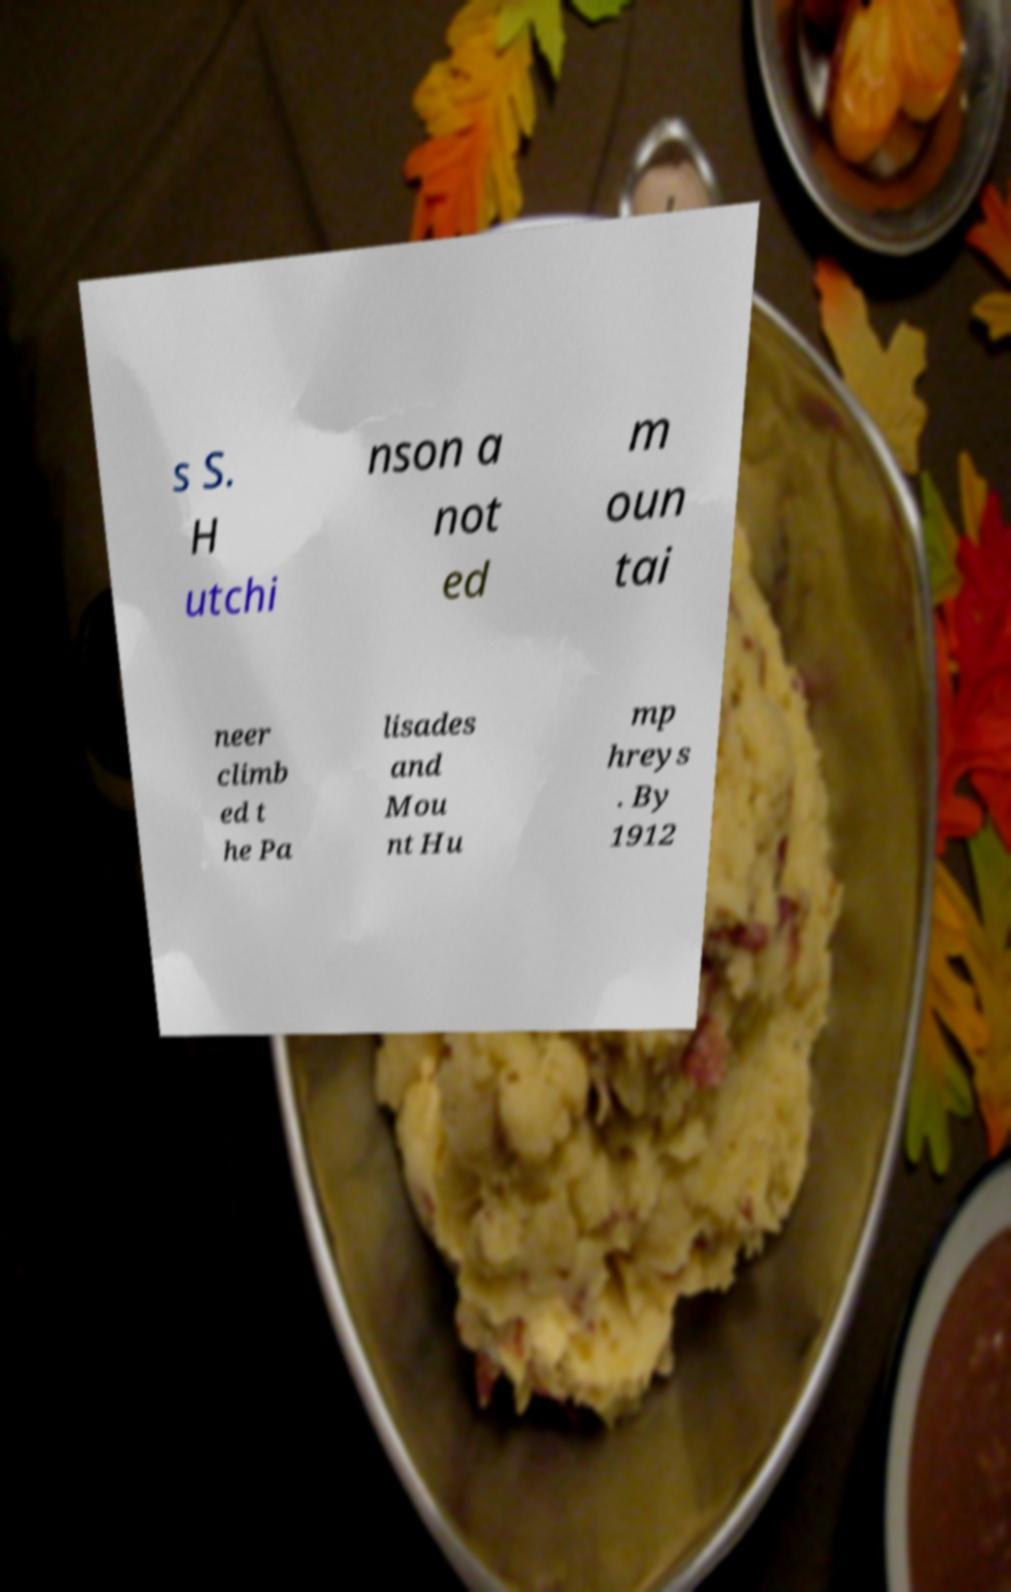Please identify and transcribe the text found in this image. s S. H utchi nson a not ed m oun tai neer climb ed t he Pa lisades and Mou nt Hu mp hreys . By 1912 